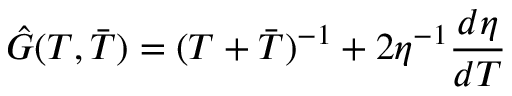Convert formula to latex. <formula><loc_0><loc_0><loc_500><loc_500>\hat { G } ( T , \bar { T } ) = ( T + \bar { T } ) ^ { - 1 } + 2 \eta ^ { - 1 } \frac { d \eta } { d T }</formula> 